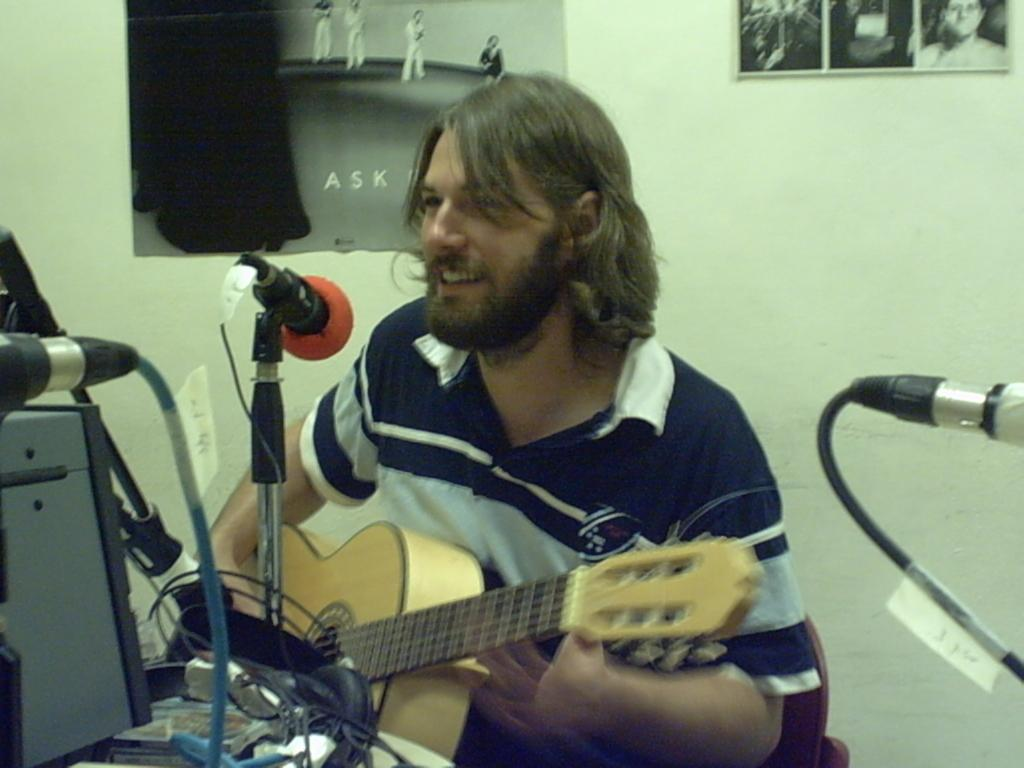What is the man in the image doing? The man is sitting on a chair and holding a guitar. What object is in front of the man? There is a microphone in front of the man. What is the microphone attached to? The microphone is attached to a microphone holder. What can be seen on the wall in the image? There are different types of pictures on the wall. What type of equipment is visible in the image? There are cables visible in the image. How many turkeys are visible in the image? There are no turkeys present in the image. What type of balls are being used by the babies in the image? There are no babies or balls present in the image. 